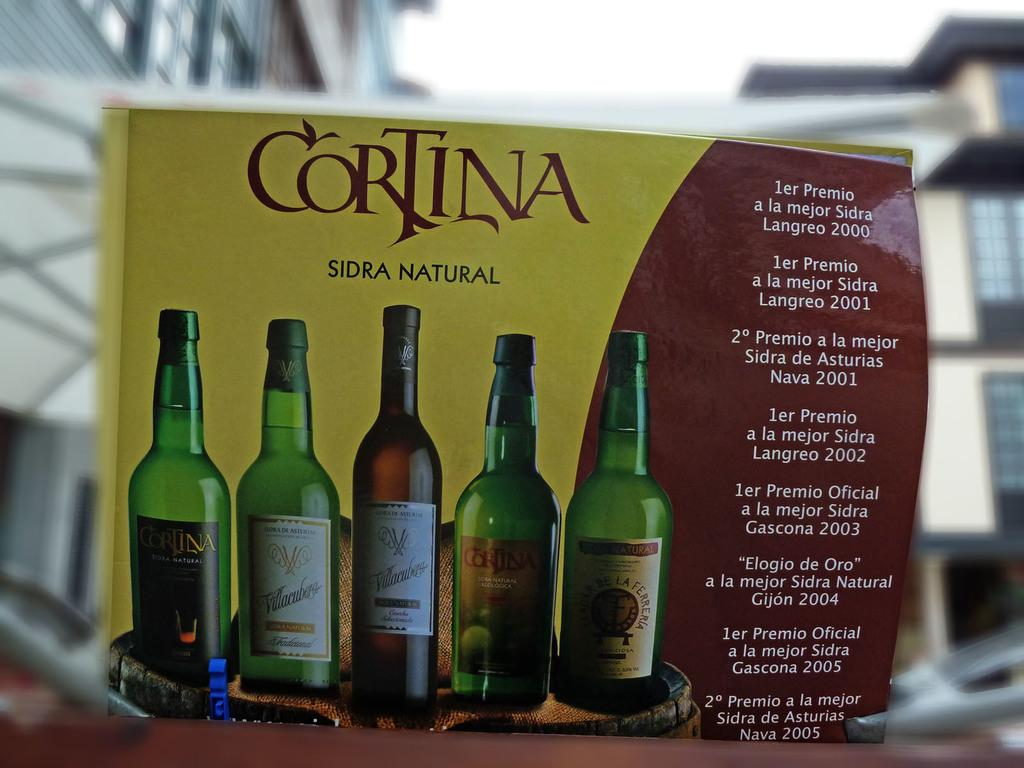<image>
Describe the image concisely. A box is shown with wines on it reading CORTINA SIDRA NATURAL at the top. 